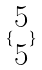<formula> <loc_0><loc_0><loc_500><loc_500>\{ \begin{matrix} 5 \\ 5 \end{matrix} \}</formula> 